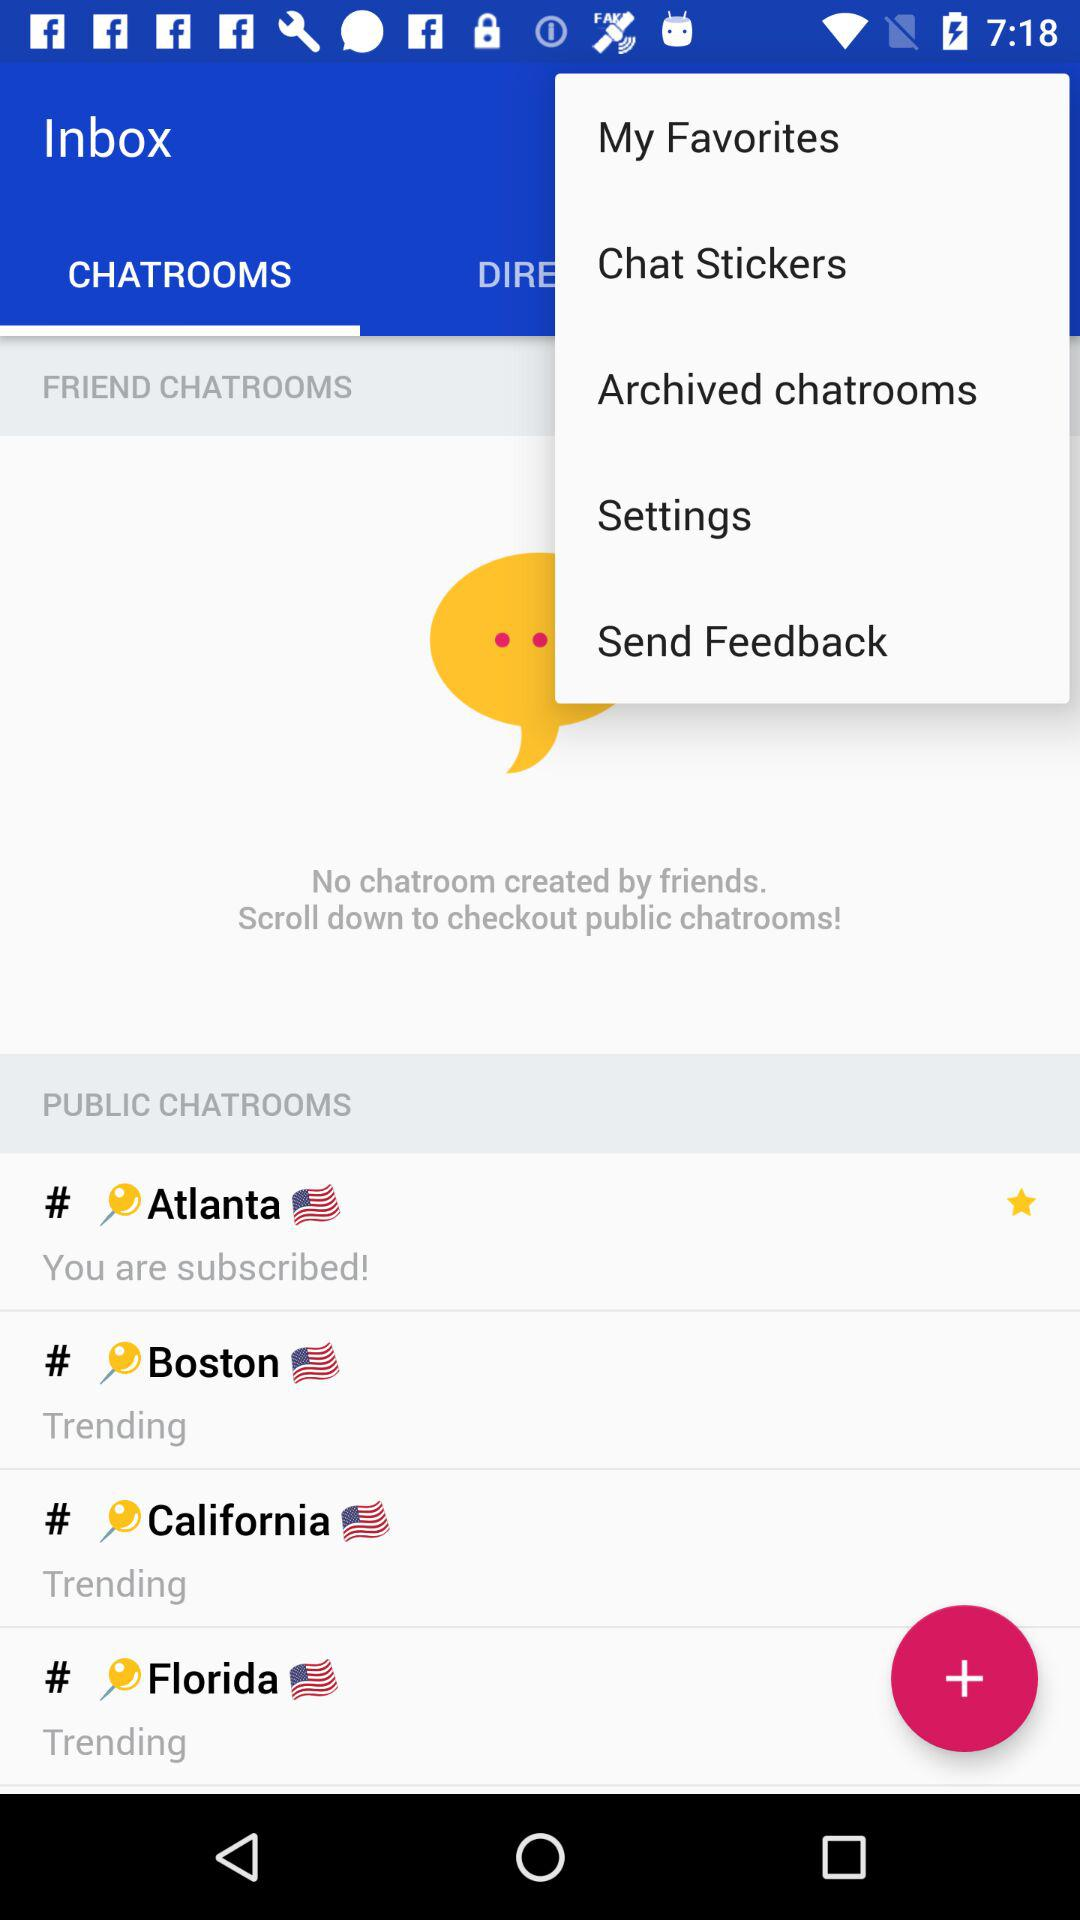How many public chatrooms are there?
Answer the question using a single word or phrase. 4 